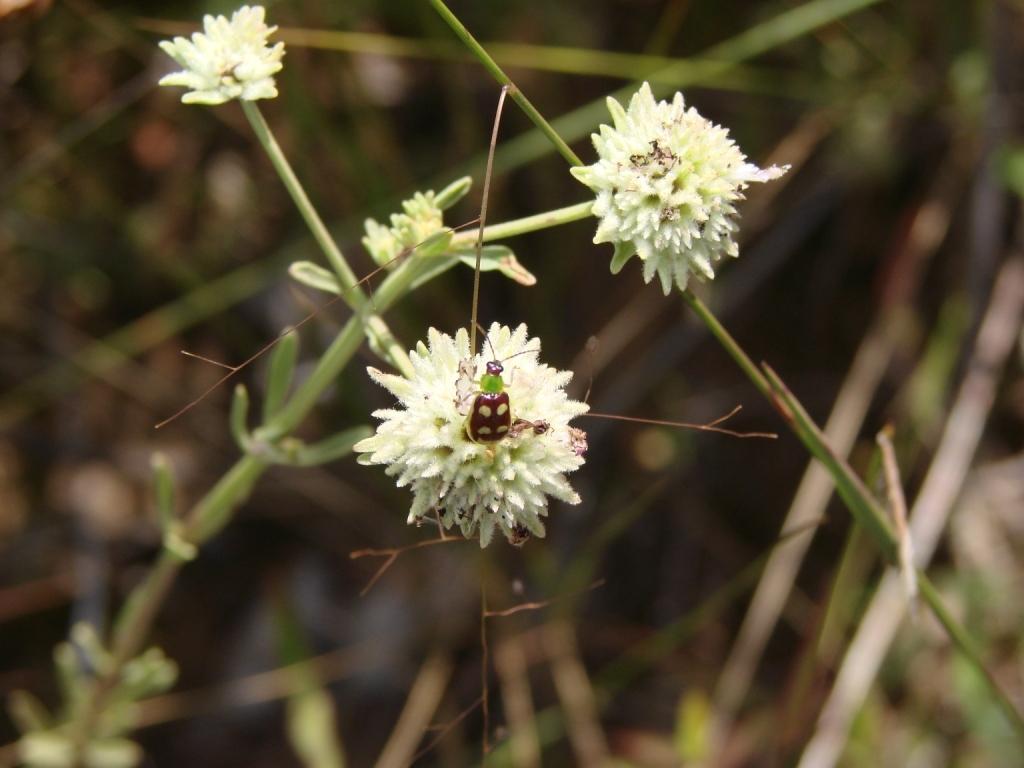Please provide a concise description of this image. In this image we can see a plant with flowers and an insect on the flower and a blurry background. 